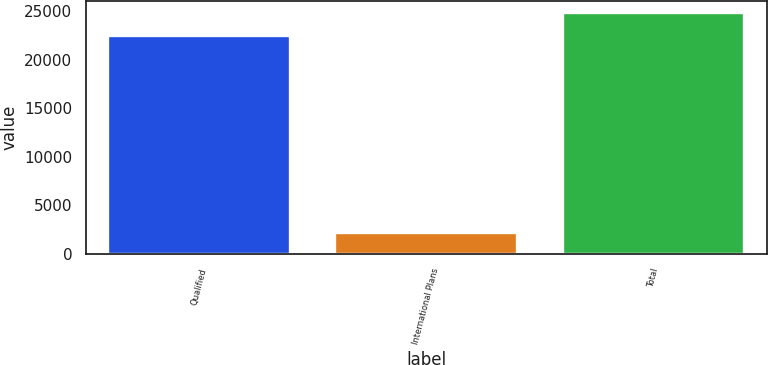Convert chart. <chart><loc_0><loc_0><loc_500><loc_500><bar_chart><fcel>Qualified<fcel>International Plans<fcel>Total<nl><fcel>22413<fcel>2167<fcel>24820<nl></chart> 